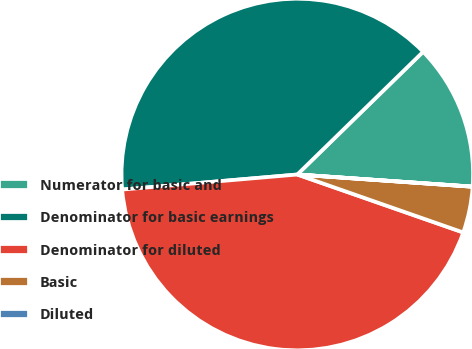Convert chart to OTSL. <chart><loc_0><loc_0><loc_500><loc_500><pie_chart><fcel>Numerator for basic and<fcel>Denominator for basic earnings<fcel>Denominator for diluted<fcel>Basic<fcel>Diluted<nl><fcel>13.4%<fcel>39.06%<fcel>43.29%<fcel>4.24%<fcel>0.01%<nl></chart> 